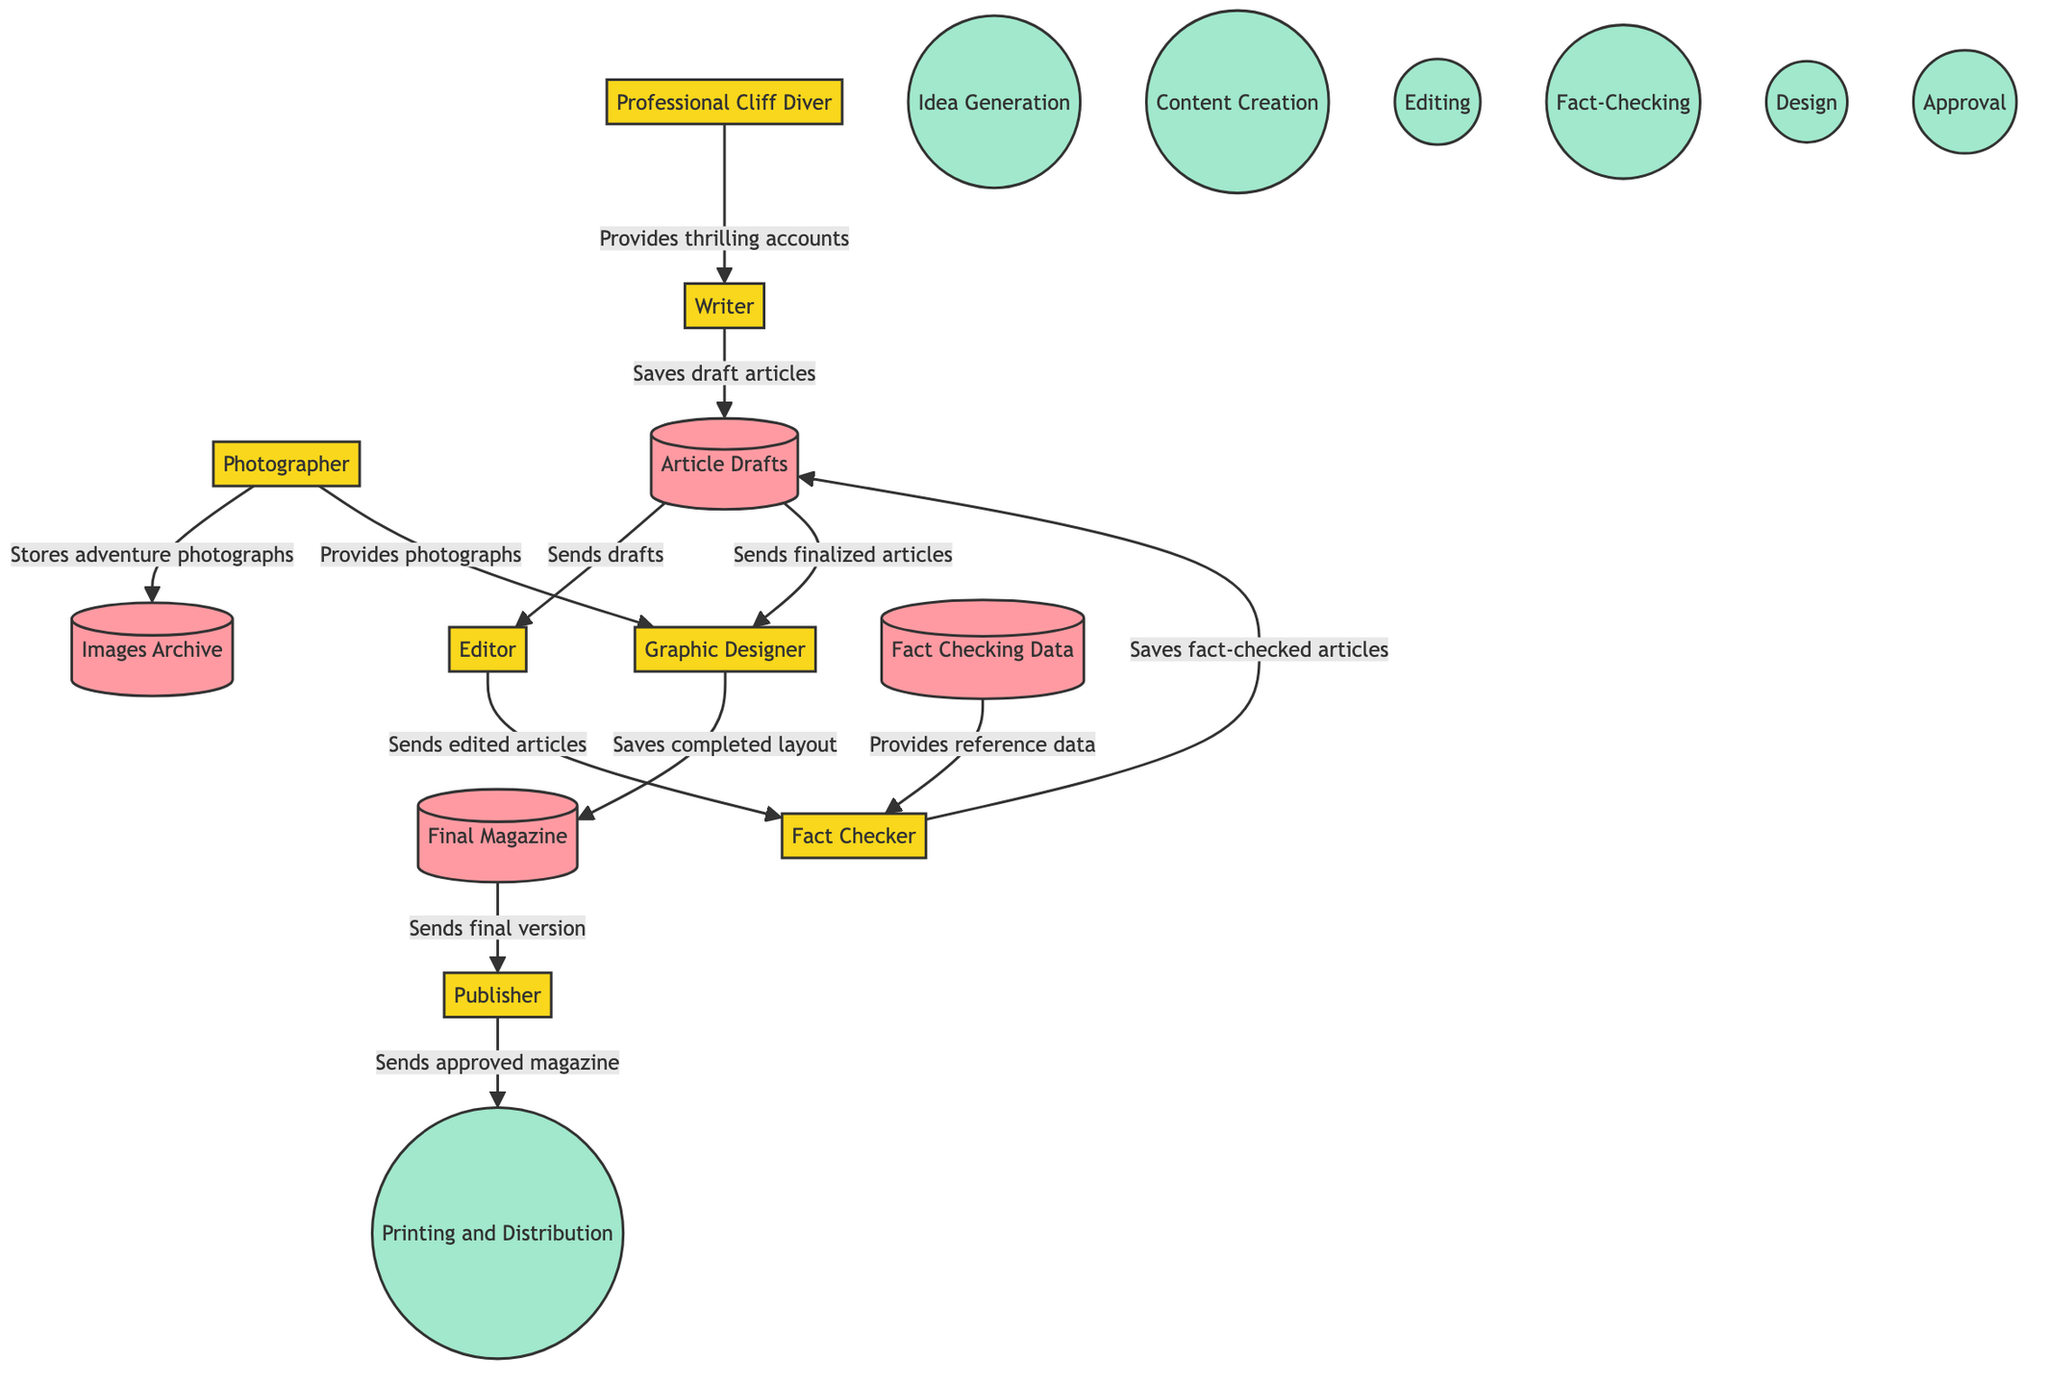What entity provides thrilling accounts and insights? The 'Professional Cliff Diver' is shown to have a direct flow to the 'Writer,' indicating that this entity provides the necessary thrilling accounts and insights for article creation.
Answer: Professional Cliff Diver How many entities are involved in the publishing workflow? The diagram shows a total of seven entities: Professional Cliff Diver, Writer, Editor, Photographer, Graphic Designer, Fact Checker, and Publisher.
Answer: Seven What data store contains the final approved version of the magazine? The 'Final Magazine' is identified as the data store that holds the completed and approved version of the magazine, as indicated in the flow from the 'Graphic Designer' to the 'Final Magazine.'
Answer: Final Magazine What is the first process in the workflow? The first process listed in the diagram is 'Idea Generation,' as it appears at the beginning of the workflow, indicating the generation of adventure topics and role assignments.
Answer: Idea Generation How does the 'Photographer' contribute to the workflow? The 'Photographer' contributes by storing adventure photographs in the 'Images Archive' and also providing these photographs to the 'Graphic Designer' for layout design, showing a dual role in the workflow.
Answer: Stores adventure photographs and provides photographs for layout design What is the final step that occurs after the Publisher's approval? After the Publisher's approval, the final step is 'Printing and Distribution,' indicating that the approved magazine is sent for printing and distribution to readers.
Answer: Printing and Distribution Which process checks the accuracy of the information in articles? 'Fact-Checking' is the process dedicated to verifying the accuracy of the information in the articles, as shown by the flow between the 'Editor' and 'Fact Checker.'
Answer: Fact-Checking What data flow occurs after the 'Fact Checker' saves fact-checked articles? After the 'Fact Checker' saves the fact-checked articles, it sends the 'Edited Articles' to the 'Graphic Designer' for designing the magazine layout, indicating the continuation of the workflow.
Answer: Sends finalized articles to the Graphic Designer How many processes are listed in the diagram? The diagram lists seven processes in total: Idea Generation, Content Creation, Editing, Fact-Checking, Design, Approval, and Printing and Distribution. This comprehensive list of processes guides the overall workflow of the publication.
Answer: Seven 